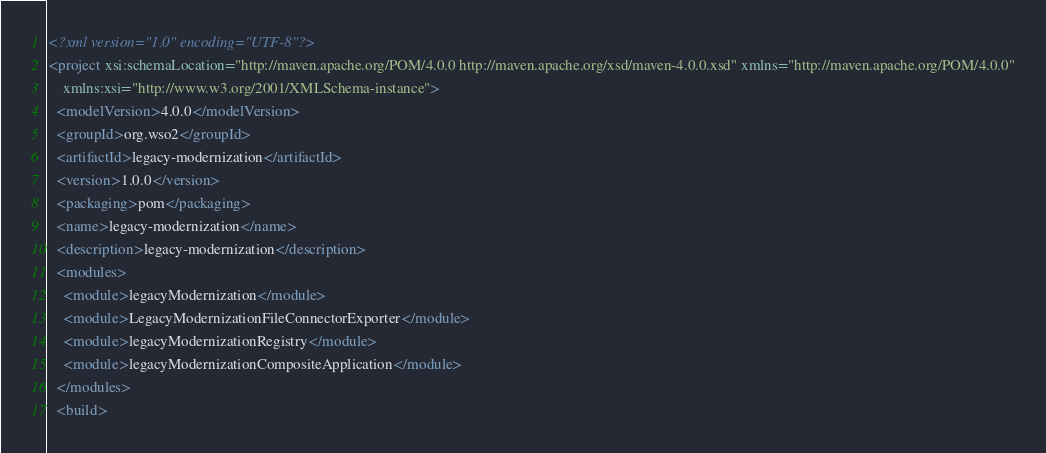Convert code to text. <code><loc_0><loc_0><loc_500><loc_500><_XML_><?xml version="1.0" encoding="UTF-8"?>
<project xsi:schemaLocation="http://maven.apache.org/POM/4.0.0 http://maven.apache.org/xsd/maven-4.0.0.xsd" xmlns="http://maven.apache.org/POM/4.0.0"
    xmlns:xsi="http://www.w3.org/2001/XMLSchema-instance">
  <modelVersion>4.0.0</modelVersion>
  <groupId>org.wso2</groupId>
  <artifactId>legacy-modernization</artifactId>
  <version>1.0.0</version>
  <packaging>pom</packaging>
  <name>legacy-modernization</name>
  <description>legacy-modernization</description>
  <modules>
    <module>legacyModernization</module>
    <module>LegacyModernizationFileConnectorExporter</module>
    <module>legacyModernizationRegistry</module>
    <module>legacyModernizationCompositeApplication</module>
  </modules>
  <build></code> 